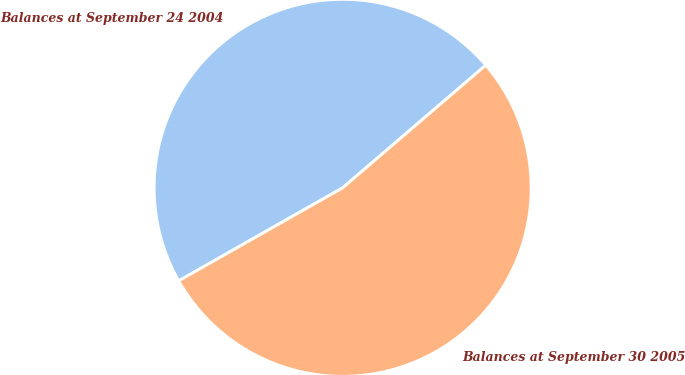<chart> <loc_0><loc_0><loc_500><loc_500><pie_chart><fcel>Balances at September 24 2004<fcel>Balances at September 30 2005<nl><fcel>46.94%<fcel>53.06%<nl></chart> 